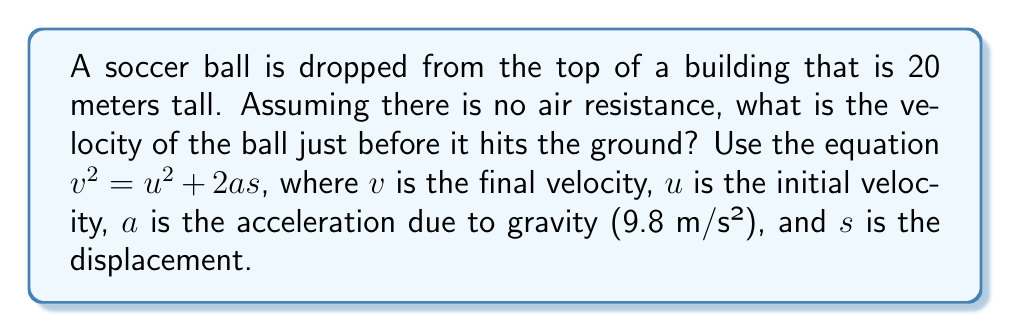Show me your answer to this math problem. Let's approach this step-by-step:

1) First, let's identify the known variables:
   - Initial velocity, $u = 0$ m/s (the ball is dropped, not thrown)
   - Acceleration due to gravity, $a = 9.8$ m/s²
   - Displacement, $s = 20$ m (the height of the building)

2) We're looking for the final velocity, $v$, just before the ball hits the ground.

3) We can use the equation: $v^2 = u^2 + 2as$

4) Let's substitute our known values:
   $$v^2 = 0^2 + 2(9.8)(20)$$

5) Simplify:
   $$v^2 = 0 + 392 = 392$$

6) To find $v$, we need to take the square root of both sides:
   $$v = \sqrt{392} = 19.8$$

7) Therefore, the velocity just before hitting the ground is 19.8 m/s.
Answer: 19.8 m/s 